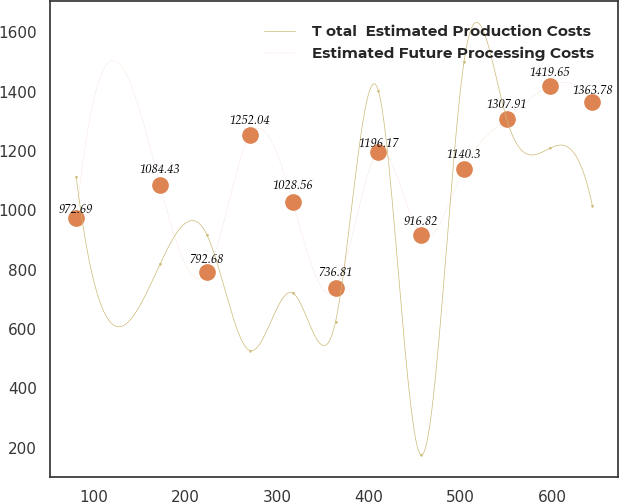<chart> <loc_0><loc_0><loc_500><loc_500><line_chart><ecel><fcel>T otal  Estimated Production Costs<fcel>Estimated Future Processing Costs<nl><fcel>80.98<fcel>1111.13<fcel>972.69<nl><fcel>172.47<fcel>819.29<fcel>1084.43<nl><fcel>223.72<fcel>916.57<fcel>792.68<nl><fcel>270.44<fcel>527.45<fcel>1252.04<nl><fcel>317.16<fcel>722.01<fcel>1028.56<nl><fcel>363.88<fcel>624.73<fcel>736.81<nl><fcel>410.6<fcel>1402.97<fcel>1196.17<nl><fcel>457.32<fcel>175.39<fcel>916.82<nl><fcel>504.04<fcel>1500.25<fcel>1140.3<nl><fcel>550.76<fcel>1305.69<fcel>1307.91<nl><fcel>597.48<fcel>1208.41<fcel>1419.65<nl><fcel>644.2<fcel>1013.85<fcel>1363.78<nl></chart> 